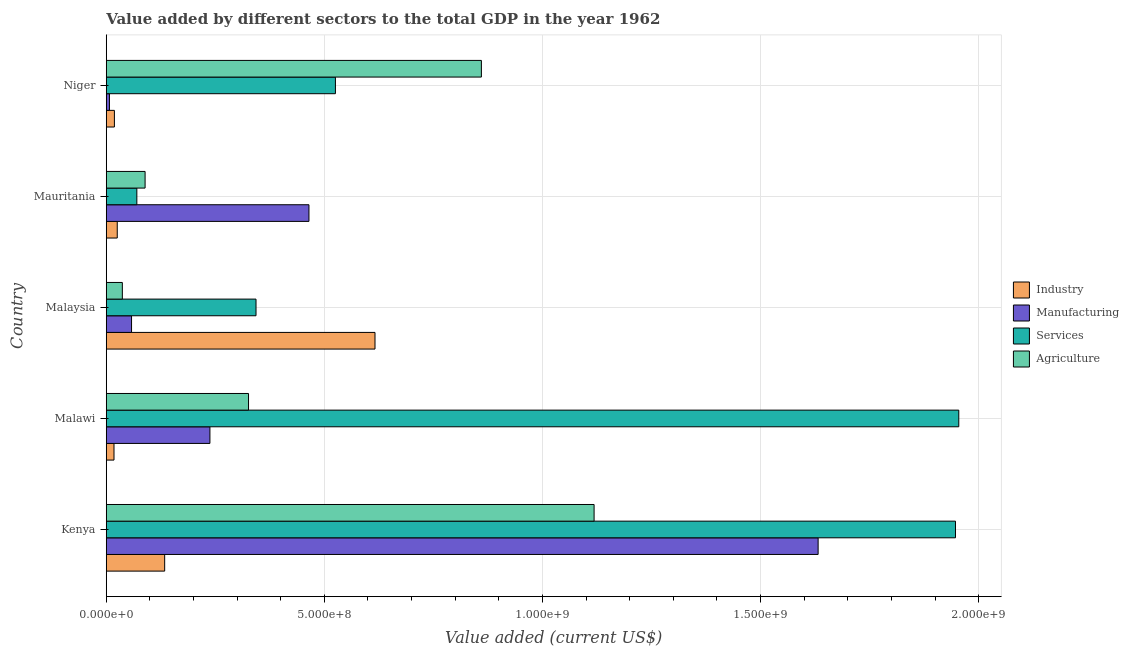Are the number of bars per tick equal to the number of legend labels?
Give a very brief answer. Yes. Are the number of bars on each tick of the Y-axis equal?
Ensure brevity in your answer.  Yes. How many bars are there on the 4th tick from the top?
Make the answer very short. 4. What is the label of the 4th group of bars from the top?
Give a very brief answer. Malawi. What is the value added by agricultural sector in Malaysia?
Offer a very short reply. 3.69e+07. Across all countries, what is the maximum value added by industrial sector?
Your answer should be very brief. 6.16e+08. Across all countries, what is the minimum value added by industrial sector?
Offer a very short reply. 1.78e+07. In which country was the value added by industrial sector maximum?
Offer a very short reply. Malaysia. In which country was the value added by agricultural sector minimum?
Offer a terse response. Malaysia. What is the total value added by manufacturing sector in the graph?
Keep it short and to the point. 2.40e+09. What is the difference between the value added by services sector in Kenya and that in Malawi?
Give a very brief answer. -7.58e+06. What is the difference between the value added by manufacturing sector in Kenya and the value added by industrial sector in Malawi?
Your response must be concise. 1.61e+09. What is the average value added by services sector per country?
Provide a short and direct response. 9.68e+08. What is the difference between the value added by industrial sector and value added by agricultural sector in Niger?
Your response must be concise. -8.41e+08. What is the ratio of the value added by industrial sector in Kenya to that in Niger?
Provide a succinct answer. 7.16. Is the difference between the value added by agricultural sector in Kenya and Malawi greater than the difference between the value added by manufacturing sector in Kenya and Malawi?
Provide a short and direct response. No. What is the difference between the highest and the second highest value added by agricultural sector?
Offer a terse response. 2.58e+08. What is the difference between the highest and the lowest value added by manufacturing sector?
Keep it short and to the point. 1.62e+09. Is it the case that in every country, the sum of the value added by agricultural sector and value added by services sector is greater than the sum of value added by industrial sector and value added by manufacturing sector?
Offer a terse response. No. What does the 2nd bar from the top in Kenya represents?
Offer a terse response. Services. What does the 3rd bar from the bottom in Kenya represents?
Your response must be concise. Services. How many bars are there?
Offer a very short reply. 20. Are the values on the major ticks of X-axis written in scientific E-notation?
Keep it short and to the point. Yes. Does the graph contain any zero values?
Provide a short and direct response. No. What is the title of the graph?
Provide a short and direct response. Value added by different sectors to the total GDP in the year 1962. What is the label or title of the X-axis?
Ensure brevity in your answer.  Value added (current US$). What is the Value added (current US$) of Industry in Kenya?
Keep it short and to the point. 1.34e+08. What is the Value added (current US$) of Manufacturing in Kenya?
Your response must be concise. 1.63e+09. What is the Value added (current US$) in Services in Kenya?
Give a very brief answer. 1.95e+09. What is the Value added (current US$) of Agriculture in Kenya?
Offer a terse response. 1.12e+09. What is the Value added (current US$) in Industry in Malawi?
Give a very brief answer. 1.78e+07. What is the Value added (current US$) in Manufacturing in Malawi?
Offer a terse response. 2.38e+08. What is the Value added (current US$) in Services in Malawi?
Ensure brevity in your answer.  1.95e+09. What is the Value added (current US$) in Agriculture in Malawi?
Keep it short and to the point. 3.26e+08. What is the Value added (current US$) in Industry in Malaysia?
Your answer should be very brief. 6.16e+08. What is the Value added (current US$) in Manufacturing in Malaysia?
Offer a very short reply. 5.80e+07. What is the Value added (current US$) in Services in Malaysia?
Your answer should be compact. 3.43e+08. What is the Value added (current US$) of Agriculture in Malaysia?
Provide a succinct answer. 3.69e+07. What is the Value added (current US$) in Industry in Mauritania?
Provide a short and direct response. 2.52e+07. What is the Value added (current US$) of Manufacturing in Mauritania?
Your answer should be very brief. 4.65e+08. What is the Value added (current US$) of Services in Mauritania?
Make the answer very short. 7.01e+07. What is the Value added (current US$) in Agriculture in Mauritania?
Make the answer very short. 8.90e+07. What is the Value added (current US$) in Industry in Niger?
Give a very brief answer. 1.87e+07. What is the Value added (current US$) in Manufacturing in Niger?
Provide a succinct answer. 7.35e+06. What is the Value added (current US$) in Services in Niger?
Ensure brevity in your answer.  5.25e+08. What is the Value added (current US$) of Agriculture in Niger?
Provide a short and direct response. 8.60e+08. Across all countries, what is the maximum Value added (current US$) of Industry?
Offer a very short reply. 6.16e+08. Across all countries, what is the maximum Value added (current US$) of Manufacturing?
Your response must be concise. 1.63e+09. Across all countries, what is the maximum Value added (current US$) of Services?
Give a very brief answer. 1.95e+09. Across all countries, what is the maximum Value added (current US$) of Agriculture?
Make the answer very short. 1.12e+09. Across all countries, what is the minimum Value added (current US$) in Industry?
Give a very brief answer. 1.78e+07. Across all countries, what is the minimum Value added (current US$) in Manufacturing?
Offer a terse response. 7.35e+06. Across all countries, what is the minimum Value added (current US$) of Services?
Your response must be concise. 7.01e+07. Across all countries, what is the minimum Value added (current US$) in Agriculture?
Offer a terse response. 3.69e+07. What is the total Value added (current US$) in Industry in the graph?
Your answer should be very brief. 8.12e+08. What is the total Value added (current US$) of Manufacturing in the graph?
Your answer should be very brief. 2.40e+09. What is the total Value added (current US$) of Services in the graph?
Give a very brief answer. 4.84e+09. What is the total Value added (current US$) in Agriculture in the graph?
Offer a terse response. 2.43e+09. What is the difference between the Value added (current US$) of Industry in Kenya and that in Malawi?
Keep it short and to the point. 1.16e+08. What is the difference between the Value added (current US$) of Manufacturing in Kenya and that in Malawi?
Provide a short and direct response. 1.39e+09. What is the difference between the Value added (current US$) in Services in Kenya and that in Malawi?
Keep it short and to the point. -7.58e+06. What is the difference between the Value added (current US$) of Agriculture in Kenya and that in Malawi?
Offer a very short reply. 7.92e+08. What is the difference between the Value added (current US$) in Industry in Kenya and that in Malaysia?
Make the answer very short. -4.82e+08. What is the difference between the Value added (current US$) in Manufacturing in Kenya and that in Malaysia?
Keep it short and to the point. 1.57e+09. What is the difference between the Value added (current US$) in Services in Kenya and that in Malaysia?
Offer a very short reply. 1.60e+09. What is the difference between the Value added (current US$) in Agriculture in Kenya and that in Malaysia?
Give a very brief answer. 1.08e+09. What is the difference between the Value added (current US$) of Industry in Kenya and that in Mauritania?
Provide a short and direct response. 1.09e+08. What is the difference between the Value added (current US$) of Manufacturing in Kenya and that in Mauritania?
Provide a succinct answer. 1.17e+09. What is the difference between the Value added (current US$) of Services in Kenya and that in Mauritania?
Your response must be concise. 1.88e+09. What is the difference between the Value added (current US$) in Agriculture in Kenya and that in Mauritania?
Make the answer very short. 1.03e+09. What is the difference between the Value added (current US$) of Industry in Kenya and that in Niger?
Ensure brevity in your answer.  1.15e+08. What is the difference between the Value added (current US$) in Manufacturing in Kenya and that in Niger?
Offer a very short reply. 1.62e+09. What is the difference between the Value added (current US$) in Services in Kenya and that in Niger?
Give a very brief answer. 1.42e+09. What is the difference between the Value added (current US$) of Agriculture in Kenya and that in Niger?
Your response must be concise. 2.58e+08. What is the difference between the Value added (current US$) in Industry in Malawi and that in Malaysia?
Give a very brief answer. -5.98e+08. What is the difference between the Value added (current US$) in Manufacturing in Malawi and that in Malaysia?
Your response must be concise. 1.80e+08. What is the difference between the Value added (current US$) of Services in Malawi and that in Malaysia?
Offer a terse response. 1.61e+09. What is the difference between the Value added (current US$) in Agriculture in Malawi and that in Malaysia?
Make the answer very short. 2.89e+08. What is the difference between the Value added (current US$) in Industry in Malawi and that in Mauritania?
Offer a terse response. -7.44e+06. What is the difference between the Value added (current US$) of Manufacturing in Malawi and that in Mauritania?
Provide a short and direct response. -2.27e+08. What is the difference between the Value added (current US$) in Services in Malawi and that in Mauritania?
Your answer should be compact. 1.88e+09. What is the difference between the Value added (current US$) of Agriculture in Malawi and that in Mauritania?
Provide a short and direct response. 2.37e+08. What is the difference between the Value added (current US$) of Industry in Malawi and that in Niger?
Provide a short and direct response. -9.35e+05. What is the difference between the Value added (current US$) in Manufacturing in Malawi and that in Niger?
Offer a terse response. 2.30e+08. What is the difference between the Value added (current US$) of Services in Malawi and that in Niger?
Your response must be concise. 1.43e+09. What is the difference between the Value added (current US$) of Agriculture in Malawi and that in Niger?
Make the answer very short. -5.34e+08. What is the difference between the Value added (current US$) in Industry in Malaysia and that in Mauritania?
Keep it short and to the point. 5.91e+08. What is the difference between the Value added (current US$) of Manufacturing in Malaysia and that in Mauritania?
Give a very brief answer. -4.07e+08. What is the difference between the Value added (current US$) in Services in Malaysia and that in Mauritania?
Ensure brevity in your answer.  2.73e+08. What is the difference between the Value added (current US$) in Agriculture in Malaysia and that in Mauritania?
Provide a succinct answer. -5.21e+07. What is the difference between the Value added (current US$) of Industry in Malaysia and that in Niger?
Provide a short and direct response. 5.97e+08. What is the difference between the Value added (current US$) in Manufacturing in Malaysia and that in Niger?
Provide a short and direct response. 5.07e+07. What is the difference between the Value added (current US$) in Services in Malaysia and that in Niger?
Your answer should be compact. -1.82e+08. What is the difference between the Value added (current US$) of Agriculture in Malaysia and that in Niger?
Provide a succinct answer. -8.23e+08. What is the difference between the Value added (current US$) of Industry in Mauritania and that in Niger?
Offer a very short reply. 6.51e+06. What is the difference between the Value added (current US$) of Manufacturing in Mauritania and that in Niger?
Your answer should be very brief. 4.57e+08. What is the difference between the Value added (current US$) in Services in Mauritania and that in Niger?
Provide a short and direct response. -4.55e+08. What is the difference between the Value added (current US$) of Agriculture in Mauritania and that in Niger?
Offer a very short reply. -7.71e+08. What is the difference between the Value added (current US$) in Industry in Kenya and the Value added (current US$) in Manufacturing in Malawi?
Offer a very short reply. -1.04e+08. What is the difference between the Value added (current US$) of Industry in Kenya and the Value added (current US$) of Services in Malawi?
Provide a short and direct response. -1.82e+09. What is the difference between the Value added (current US$) of Industry in Kenya and the Value added (current US$) of Agriculture in Malawi?
Your response must be concise. -1.92e+08. What is the difference between the Value added (current US$) of Manufacturing in Kenya and the Value added (current US$) of Services in Malawi?
Make the answer very short. -3.22e+08. What is the difference between the Value added (current US$) of Manufacturing in Kenya and the Value added (current US$) of Agriculture in Malawi?
Keep it short and to the point. 1.31e+09. What is the difference between the Value added (current US$) in Services in Kenya and the Value added (current US$) in Agriculture in Malawi?
Provide a succinct answer. 1.62e+09. What is the difference between the Value added (current US$) of Industry in Kenya and the Value added (current US$) of Manufacturing in Malaysia?
Your response must be concise. 7.59e+07. What is the difference between the Value added (current US$) in Industry in Kenya and the Value added (current US$) in Services in Malaysia?
Offer a terse response. -2.09e+08. What is the difference between the Value added (current US$) of Industry in Kenya and the Value added (current US$) of Agriculture in Malaysia?
Make the answer very short. 9.70e+07. What is the difference between the Value added (current US$) of Manufacturing in Kenya and the Value added (current US$) of Services in Malaysia?
Make the answer very short. 1.29e+09. What is the difference between the Value added (current US$) of Manufacturing in Kenya and the Value added (current US$) of Agriculture in Malaysia?
Provide a succinct answer. 1.60e+09. What is the difference between the Value added (current US$) in Services in Kenya and the Value added (current US$) in Agriculture in Malaysia?
Keep it short and to the point. 1.91e+09. What is the difference between the Value added (current US$) in Industry in Kenya and the Value added (current US$) in Manufacturing in Mauritania?
Provide a succinct answer. -3.31e+08. What is the difference between the Value added (current US$) in Industry in Kenya and the Value added (current US$) in Services in Mauritania?
Provide a short and direct response. 6.38e+07. What is the difference between the Value added (current US$) of Industry in Kenya and the Value added (current US$) of Agriculture in Mauritania?
Your response must be concise. 4.49e+07. What is the difference between the Value added (current US$) of Manufacturing in Kenya and the Value added (current US$) of Services in Mauritania?
Make the answer very short. 1.56e+09. What is the difference between the Value added (current US$) of Manufacturing in Kenya and the Value added (current US$) of Agriculture in Mauritania?
Your response must be concise. 1.54e+09. What is the difference between the Value added (current US$) in Services in Kenya and the Value added (current US$) in Agriculture in Mauritania?
Your response must be concise. 1.86e+09. What is the difference between the Value added (current US$) of Industry in Kenya and the Value added (current US$) of Manufacturing in Niger?
Your answer should be compact. 1.27e+08. What is the difference between the Value added (current US$) in Industry in Kenya and the Value added (current US$) in Services in Niger?
Make the answer very short. -3.91e+08. What is the difference between the Value added (current US$) in Industry in Kenya and the Value added (current US$) in Agriculture in Niger?
Ensure brevity in your answer.  -7.26e+08. What is the difference between the Value added (current US$) of Manufacturing in Kenya and the Value added (current US$) of Services in Niger?
Offer a terse response. 1.11e+09. What is the difference between the Value added (current US$) in Manufacturing in Kenya and the Value added (current US$) in Agriculture in Niger?
Provide a short and direct response. 7.72e+08. What is the difference between the Value added (current US$) of Services in Kenya and the Value added (current US$) of Agriculture in Niger?
Keep it short and to the point. 1.09e+09. What is the difference between the Value added (current US$) in Industry in Malawi and the Value added (current US$) in Manufacturing in Malaysia?
Your answer should be very brief. -4.02e+07. What is the difference between the Value added (current US$) in Industry in Malawi and the Value added (current US$) in Services in Malaysia?
Keep it short and to the point. -3.26e+08. What is the difference between the Value added (current US$) in Industry in Malawi and the Value added (current US$) in Agriculture in Malaysia?
Keep it short and to the point. -1.91e+07. What is the difference between the Value added (current US$) in Manufacturing in Malawi and the Value added (current US$) in Services in Malaysia?
Provide a succinct answer. -1.06e+08. What is the difference between the Value added (current US$) in Manufacturing in Malawi and the Value added (current US$) in Agriculture in Malaysia?
Provide a short and direct response. 2.01e+08. What is the difference between the Value added (current US$) of Services in Malawi and the Value added (current US$) of Agriculture in Malaysia?
Give a very brief answer. 1.92e+09. What is the difference between the Value added (current US$) in Industry in Malawi and the Value added (current US$) in Manufacturing in Mauritania?
Your answer should be compact. -4.47e+08. What is the difference between the Value added (current US$) in Industry in Malawi and the Value added (current US$) in Services in Mauritania?
Give a very brief answer. -5.24e+07. What is the difference between the Value added (current US$) of Industry in Malawi and the Value added (current US$) of Agriculture in Mauritania?
Offer a terse response. -7.13e+07. What is the difference between the Value added (current US$) in Manufacturing in Malawi and the Value added (current US$) in Services in Mauritania?
Keep it short and to the point. 1.68e+08. What is the difference between the Value added (current US$) of Manufacturing in Malawi and the Value added (current US$) of Agriculture in Mauritania?
Your answer should be very brief. 1.49e+08. What is the difference between the Value added (current US$) in Services in Malawi and the Value added (current US$) in Agriculture in Mauritania?
Give a very brief answer. 1.87e+09. What is the difference between the Value added (current US$) in Industry in Malawi and the Value added (current US$) in Manufacturing in Niger?
Provide a succinct answer. 1.04e+07. What is the difference between the Value added (current US$) in Industry in Malawi and the Value added (current US$) in Services in Niger?
Your answer should be compact. -5.08e+08. What is the difference between the Value added (current US$) of Industry in Malawi and the Value added (current US$) of Agriculture in Niger?
Offer a very short reply. -8.42e+08. What is the difference between the Value added (current US$) of Manufacturing in Malawi and the Value added (current US$) of Services in Niger?
Offer a terse response. -2.88e+08. What is the difference between the Value added (current US$) in Manufacturing in Malawi and the Value added (current US$) in Agriculture in Niger?
Ensure brevity in your answer.  -6.22e+08. What is the difference between the Value added (current US$) of Services in Malawi and the Value added (current US$) of Agriculture in Niger?
Offer a very short reply. 1.09e+09. What is the difference between the Value added (current US$) of Industry in Malaysia and the Value added (current US$) of Manufacturing in Mauritania?
Your response must be concise. 1.51e+08. What is the difference between the Value added (current US$) of Industry in Malaysia and the Value added (current US$) of Services in Mauritania?
Your answer should be compact. 5.46e+08. What is the difference between the Value added (current US$) in Industry in Malaysia and the Value added (current US$) in Agriculture in Mauritania?
Give a very brief answer. 5.27e+08. What is the difference between the Value added (current US$) of Manufacturing in Malaysia and the Value added (current US$) of Services in Mauritania?
Your response must be concise. -1.21e+07. What is the difference between the Value added (current US$) in Manufacturing in Malaysia and the Value added (current US$) in Agriculture in Mauritania?
Provide a short and direct response. -3.10e+07. What is the difference between the Value added (current US$) in Services in Malaysia and the Value added (current US$) in Agriculture in Mauritania?
Your answer should be very brief. 2.54e+08. What is the difference between the Value added (current US$) of Industry in Malaysia and the Value added (current US$) of Manufacturing in Niger?
Your answer should be compact. 6.09e+08. What is the difference between the Value added (current US$) of Industry in Malaysia and the Value added (current US$) of Services in Niger?
Give a very brief answer. 9.07e+07. What is the difference between the Value added (current US$) of Industry in Malaysia and the Value added (current US$) of Agriculture in Niger?
Keep it short and to the point. -2.44e+08. What is the difference between the Value added (current US$) of Manufacturing in Malaysia and the Value added (current US$) of Services in Niger?
Give a very brief answer. -4.67e+08. What is the difference between the Value added (current US$) of Manufacturing in Malaysia and the Value added (current US$) of Agriculture in Niger?
Provide a short and direct response. -8.02e+08. What is the difference between the Value added (current US$) in Services in Malaysia and the Value added (current US$) in Agriculture in Niger?
Offer a very short reply. -5.17e+08. What is the difference between the Value added (current US$) of Industry in Mauritania and the Value added (current US$) of Manufacturing in Niger?
Your response must be concise. 1.79e+07. What is the difference between the Value added (current US$) of Industry in Mauritania and the Value added (current US$) of Services in Niger?
Your answer should be very brief. -5.00e+08. What is the difference between the Value added (current US$) of Industry in Mauritania and the Value added (current US$) of Agriculture in Niger?
Provide a short and direct response. -8.35e+08. What is the difference between the Value added (current US$) of Manufacturing in Mauritania and the Value added (current US$) of Services in Niger?
Offer a very short reply. -6.07e+07. What is the difference between the Value added (current US$) of Manufacturing in Mauritania and the Value added (current US$) of Agriculture in Niger?
Your answer should be compact. -3.95e+08. What is the difference between the Value added (current US$) in Services in Mauritania and the Value added (current US$) in Agriculture in Niger?
Offer a terse response. -7.90e+08. What is the average Value added (current US$) of Industry per country?
Ensure brevity in your answer.  1.62e+08. What is the average Value added (current US$) of Manufacturing per country?
Offer a terse response. 4.80e+08. What is the average Value added (current US$) in Services per country?
Make the answer very short. 9.68e+08. What is the average Value added (current US$) of Agriculture per country?
Make the answer very short. 4.86e+08. What is the difference between the Value added (current US$) of Industry and Value added (current US$) of Manufacturing in Kenya?
Ensure brevity in your answer.  -1.50e+09. What is the difference between the Value added (current US$) in Industry and Value added (current US$) in Services in Kenya?
Your response must be concise. -1.81e+09. What is the difference between the Value added (current US$) in Industry and Value added (current US$) in Agriculture in Kenya?
Your answer should be very brief. -9.84e+08. What is the difference between the Value added (current US$) in Manufacturing and Value added (current US$) in Services in Kenya?
Offer a very short reply. -3.15e+08. What is the difference between the Value added (current US$) in Manufacturing and Value added (current US$) in Agriculture in Kenya?
Provide a short and direct response. 5.14e+08. What is the difference between the Value added (current US$) in Services and Value added (current US$) in Agriculture in Kenya?
Give a very brief answer. 8.28e+08. What is the difference between the Value added (current US$) of Industry and Value added (current US$) of Manufacturing in Malawi?
Your answer should be compact. -2.20e+08. What is the difference between the Value added (current US$) of Industry and Value added (current US$) of Services in Malawi?
Your answer should be very brief. -1.94e+09. What is the difference between the Value added (current US$) in Industry and Value added (current US$) in Agriculture in Malawi?
Your response must be concise. -3.08e+08. What is the difference between the Value added (current US$) in Manufacturing and Value added (current US$) in Services in Malawi?
Keep it short and to the point. -1.72e+09. What is the difference between the Value added (current US$) of Manufacturing and Value added (current US$) of Agriculture in Malawi?
Provide a short and direct response. -8.85e+07. What is the difference between the Value added (current US$) of Services and Value added (current US$) of Agriculture in Malawi?
Give a very brief answer. 1.63e+09. What is the difference between the Value added (current US$) in Industry and Value added (current US$) in Manufacturing in Malaysia?
Offer a terse response. 5.58e+08. What is the difference between the Value added (current US$) in Industry and Value added (current US$) in Services in Malaysia?
Offer a very short reply. 2.73e+08. What is the difference between the Value added (current US$) of Industry and Value added (current US$) of Agriculture in Malaysia?
Ensure brevity in your answer.  5.79e+08. What is the difference between the Value added (current US$) of Manufacturing and Value added (current US$) of Services in Malaysia?
Your response must be concise. -2.85e+08. What is the difference between the Value added (current US$) of Manufacturing and Value added (current US$) of Agriculture in Malaysia?
Offer a terse response. 2.11e+07. What is the difference between the Value added (current US$) in Services and Value added (current US$) in Agriculture in Malaysia?
Keep it short and to the point. 3.06e+08. What is the difference between the Value added (current US$) in Industry and Value added (current US$) in Manufacturing in Mauritania?
Provide a succinct answer. -4.39e+08. What is the difference between the Value added (current US$) of Industry and Value added (current US$) of Services in Mauritania?
Provide a succinct answer. -4.49e+07. What is the difference between the Value added (current US$) in Industry and Value added (current US$) in Agriculture in Mauritania?
Give a very brief answer. -6.38e+07. What is the difference between the Value added (current US$) of Manufacturing and Value added (current US$) of Services in Mauritania?
Your answer should be compact. 3.95e+08. What is the difference between the Value added (current US$) of Manufacturing and Value added (current US$) of Agriculture in Mauritania?
Give a very brief answer. 3.76e+08. What is the difference between the Value added (current US$) in Services and Value added (current US$) in Agriculture in Mauritania?
Keep it short and to the point. -1.89e+07. What is the difference between the Value added (current US$) in Industry and Value added (current US$) in Manufacturing in Niger?
Your answer should be very brief. 1.14e+07. What is the difference between the Value added (current US$) of Industry and Value added (current US$) of Services in Niger?
Ensure brevity in your answer.  -5.07e+08. What is the difference between the Value added (current US$) of Industry and Value added (current US$) of Agriculture in Niger?
Your answer should be compact. -8.41e+08. What is the difference between the Value added (current US$) in Manufacturing and Value added (current US$) in Services in Niger?
Your answer should be very brief. -5.18e+08. What is the difference between the Value added (current US$) in Manufacturing and Value added (current US$) in Agriculture in Niger?
Your response must be concise. -8.53e+08. What is the difference between the Value added (current US$) of Services and Value added (current US$) of Agriculture in Niger?
Ensure brevity in your answer.  -3.35e+08. What is the ratio of the Value added (current US$) in Industry in Kenya to that in Malawi?
Your answer should be compact. 7.53. What is the ratio of the Value added (current US$) in Manufacturing in Kenya to that in Malawi?
Ensure brevity in your answer.  6.87. What is the ratio of the Value added (current US$) of Services in Kenya to that in Malawi?
Provide a succinct answer. 1. What is the ratio of the Value added (current US$) in Agriculture in Kenya to that in Malawi?
Offer a very short reply. 3.43. What is the ratio of the Value added (current US$) in Industry in Kenya to that in Malaysia?
Your answer should be compact. 0.22. What is the ratio of the Value added (current US$) of Manufacturing in Kenya to that in Malaysia?
Offer a terse response. 28.13. What is the ratio of the Value added (current US$) in Services in Kenya to that in Malaysia?
Provide a short and direct response. 5.67. What is the ratio of the Value added (current US$) of Agriculture in Kenya to that in Malaysia?
Make the answer very short. 30.3. What is the ratio of the Value added (current US$) of Industry in Kenya to that in Mauritania?
Your response must be concise. 5.31. What is the ratio of the Value added (current US$) of Manufacturing in Kenya to that in Mauritania?
Your answer should be compact. 3.51. What is the ratio of the Value added (current US$) in Services in Kenya to that in Mauritania?
Give a very brief answer. 27.76. What is the ratio of the Value added (current US$) in Agriculture in Kenya to that in Mauritania?
Offer a terse response. 12.56. What is the ratio of the Value added (current US$) in Industry in Kenya to that in Niger?
Give a very brief answer. 7.16. What is the ratio of the Value added (current US$) of Manufacturing in Kenya to that in Niger?
Your answer should be very brief. 222.14. What is the ratio of the Value added (current US$) in Services in Kenya to that in Niger?
Keep it short and to the point. 3.71. What is the ratio of the Value added (current US$) in Agriculture in Kenya to that in Niger?
Offer a terse response. 1.3. What is the ratio of the Value added (current US$) in Industry in Malawi to that in Malaysia?
Provide a succinct answer. 0.03. What is the ratio of the Value added (current US$) in Manufacturing in Malawi to that in Malaysia?
Offer a very short reply. 4.1. What is the ratio of the Value added (current US$) in Services in Malawi to that in Malaysia?
Offer a terse response. 5.69. What is the ratio of the Value added (current US$) of Agriculture in Malawi to that in Malaysia?
Make the answer very short. 8.84. What is the ratio of the Value added (current US$) of Industry in Malawi to that in Mauritania?
Offer a terse response. 0.7. What is the ratio of the Value added (current US$) in Manufacturing in Malawi to that in Mauritania?
Your response must be concise. 0.51. What is the ratio of the Value added (current US$) in Services in Malawi to that in Mauritania?
Ensure brevity in your answer.  27.86. What is the ratio of the Value added (current US$) in Agriculture in Malawi to that in Mauritania?
Give a very brief answer. 3.66. What is the ratio of the Value added (current US$) in Industry in Malawi to that in Niger?
Provide a short and direct response. 0.95. What is the ratio of the Value added (current US$) in Manufacturing in Malawi to that in Niger?
Your answer should be compact. 32.35. What is the ratio of the Value added (current US$) of Services in Malawi to that in Niger?
Your answer should be very brief. 3.72. What is the ratio of the Value added (current US$) of Agriculture in Malawi to that in Niger?
Provide a succinct answer. 0.38. What is the ratio of the Value added (current US$) in Industry in Malaysia to that in Mauritania?
Offer a very short reply. 24.43. What is the ratio of the Value added (current US$) of Manufacturing in Malaysia to that in Mauritania?
Provide a succinct answer. 0.12. What is the ratio of the Value added (current US$) of Services in Malaysia to that in Mauritania?
Your answer should be compact. 4.89. What is the ratio of the Value added (current US$) of Agriculture in Malaysia to that in Mauritania?
Provide a short and direct response. 0.41. What is the ratio of the Value added (current US$) in Industry in Malaysia to that in Niger?
Make the answer very short. 32.92. What is the ratio of the Value added (current US$) of Manufacturing in Malaysia to that in Niger?
Give a very brief answer. 7.9. What is the ratio of the Value added (current US$) of Services in Malaysia to that in Niger?
Provide a succinct answer. 0.65. What is the ratio of the Value added (current US$) in Agriculture in Malaysia to that in Niger?
Offer a terse response. 0.04. What is the ratio of the Value added (current US$) of Industry in Mauritania to that in Niger?
Provide a succinct answer. 1.35. What is the ratio of the Value added (current US$) of Manufacturing in Mauritania to that in Niger?
Offer a terse response. 63.26. What is the ratio of the Value added (current US$) of Services in Mauritania to that in Niger?
Provide a succinct answer. 0.13. What is the ratio of the Value added (current US$) of Agriculture in Mauritania to that in Niger?
Offer a terse response. 0.1. What is the difference between the highest and the second highest Value added (current US$) of Industry?
Your response must be concise. 4.82e+08. What is the difference between the highest and the second highest Value added (current US$) of Manufacturing?
Your response must be concise. 1.17e+09. What is the difference between the highest and the second highest Value added (current US$) in Services?
Provide a succinct answer. 7.58e+06. What is the difference between the highest and the second highest Value added (current US$) of Agriculture?
Your answer should be compact. 2.58e+08. What is the difference between the highest and the lowest Value added (current US$) of Industry?
Keep it short and to the point. 5.98e+08. What is the difference between the highest and the lowest Value added (current US$) in Manufacturing?
Keep it short and to the point. 1.62e+09. What is the difference between the highest and the lowest Value added (current US$) of Services?
Offer a very short reply. 1.88e+09. What is the difference between the highest and the lowest Value added (current US$) in Agriculture?
Provide a succinct answer. 1.08e+09. 